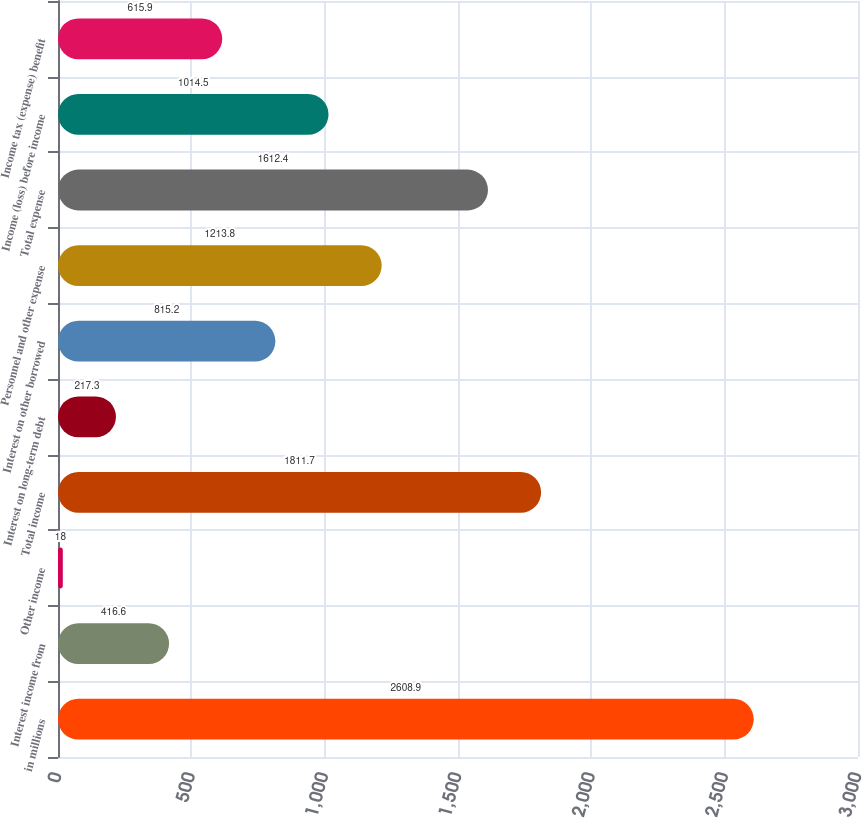Convert chart to OTSL. <chart><loc_0><loc_0><loc_500><loc_500><bar_chart><fcel>in millions<fcel>Interest income from<fcel>Other income<fcel>Total income<fcel>Interest on long-term debt<fcel>Interest on other borrowed<fcel>Personnel and other expense<fcel>Total expense<fcel>Income (loss) before income<fcel>Income tax (expense) benefit<nl><fcel>2608.9<fcel>416.6<fcel>18<fcel>1811.7<fcel>217.3<fcel>815.2<fcel>1213.8<fcel>1612.4<fcel>1014.5<fcel>615.9<nl></chart> 